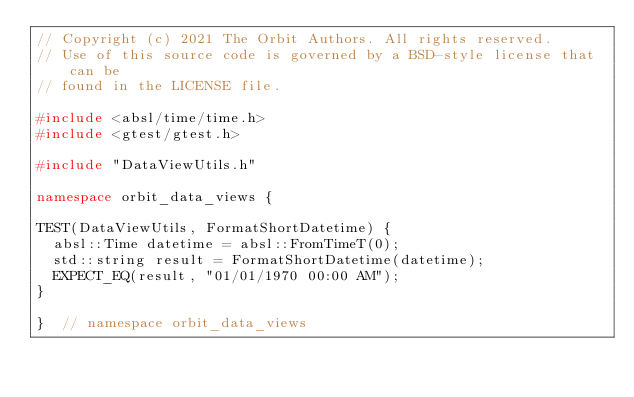Convert code to text. <code><loc_0><loc_0><loc_500><loc_500><_C++_>// Copyright (c) 2021 The Orbit Authors. All rights reserved.
// Use of this source code is governed by a BSD-style license that can be
// found in the LICENSE file.

#include <absl/time/time.h>
#include <gtest/gtest.h>

#include "DataViewUtils.h"

namespace orbit_data_views {

TEST(DataViewUtils, FormatShortDatetime) {
  absl::Time datetime = absl::FromTimeT(0);
  std::string result = FormatShortDatetime(datetime);
  EXPECT_EQ(result, "01/01/1970 00:00 AM");
}

}  // namespace orbit_data_views</code> 